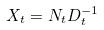Convert formula to latex. <formula><loc_0><loc_0><loc_500><loc_500>X _ { t } = N _ { t } D _ { t } ^ { - 1 }</formula> 